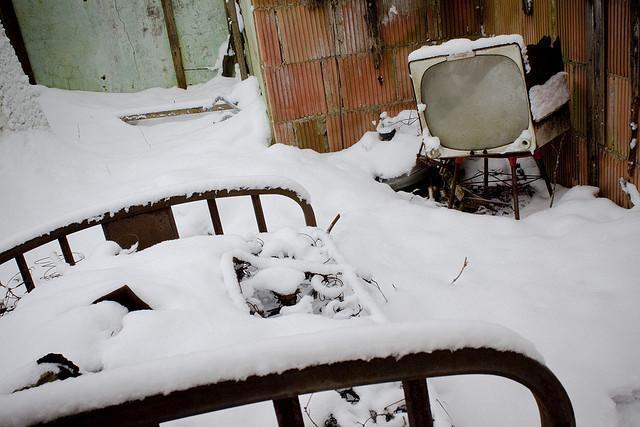How many coca-cola bottles are there?
Give a very brief answer. 0. 